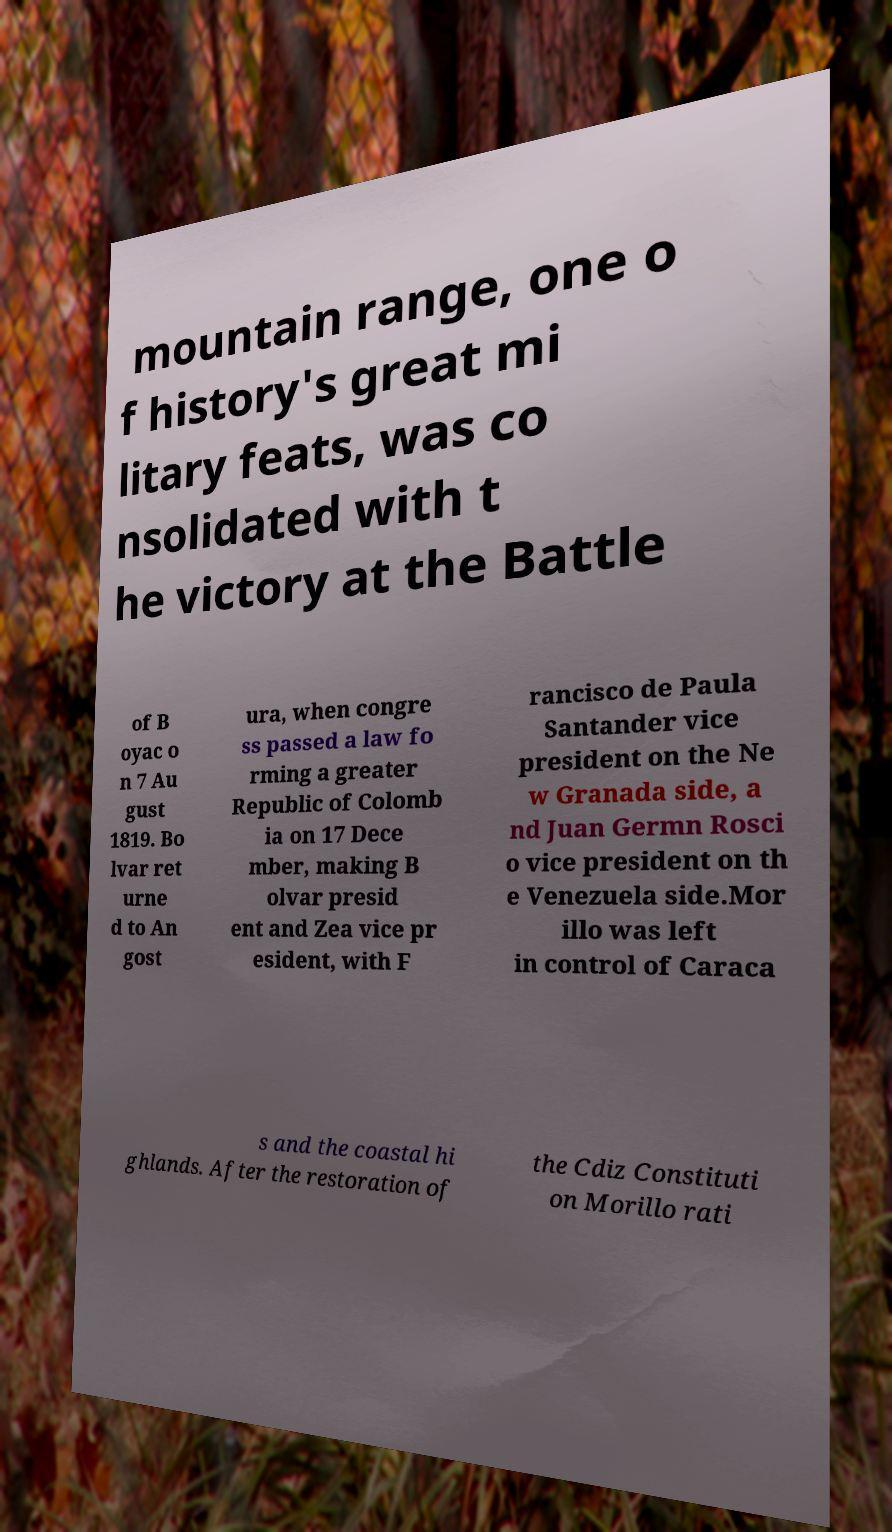Can you read and provide the text displayed in the image?This photo seems to have some interesting text. Can you extract and type it out for me? mountain range, one o f history's great mi litary feats, was co nsolidated with t he victory at the Battle of B oyac o n 7 Au gust 1819. Bo lvar ret urne d to An gost ura, when congre ss passed a law fo rming a greater Republic of Colomb ia on 17 Dece mber, making B olvar presid ent and Zea vice pr esident, with F rancisco de Paula Santander vice president on the Ne w Granada side, a nd Juan Germn Rosci o vice president on th e Venezuela side.Mor illo was left in control of Caraca s and the coastal hi ghlands. After the restoration of the Cdiz Constituti on Morillo rati 